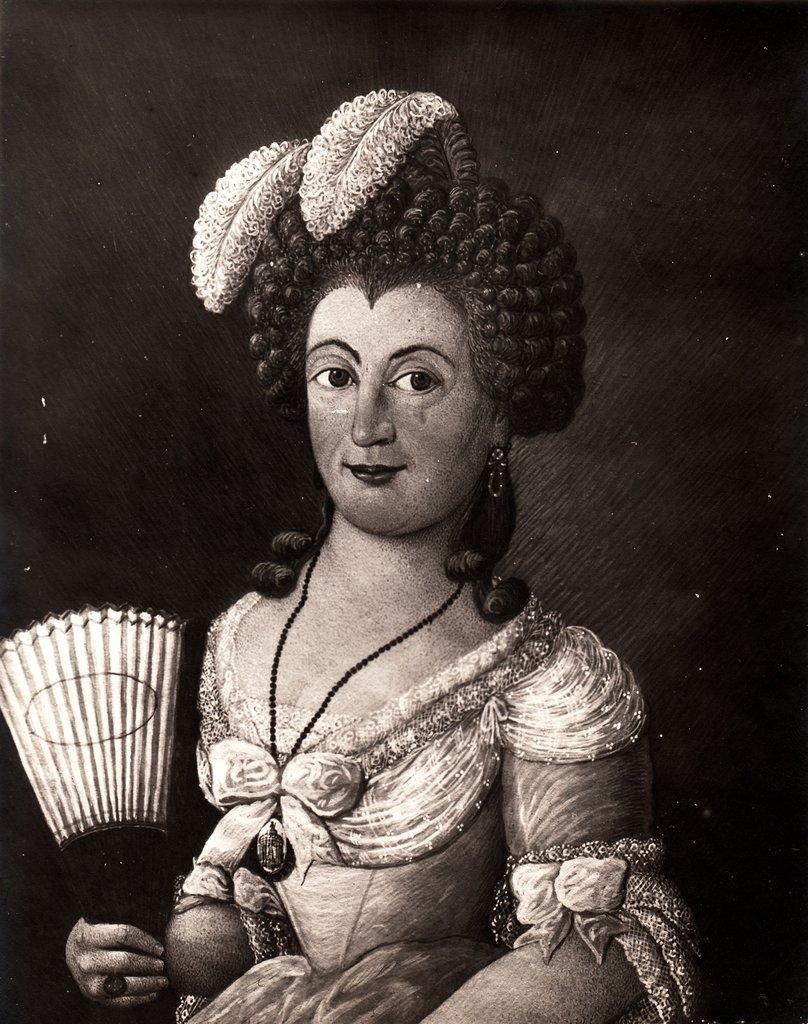How would you summarize this image in a sentence or two? This picture seems to be a painting. In the center of this picture there is a woman holding a hand fan, wearing a dress and smiling. The background of the image is very dark. 